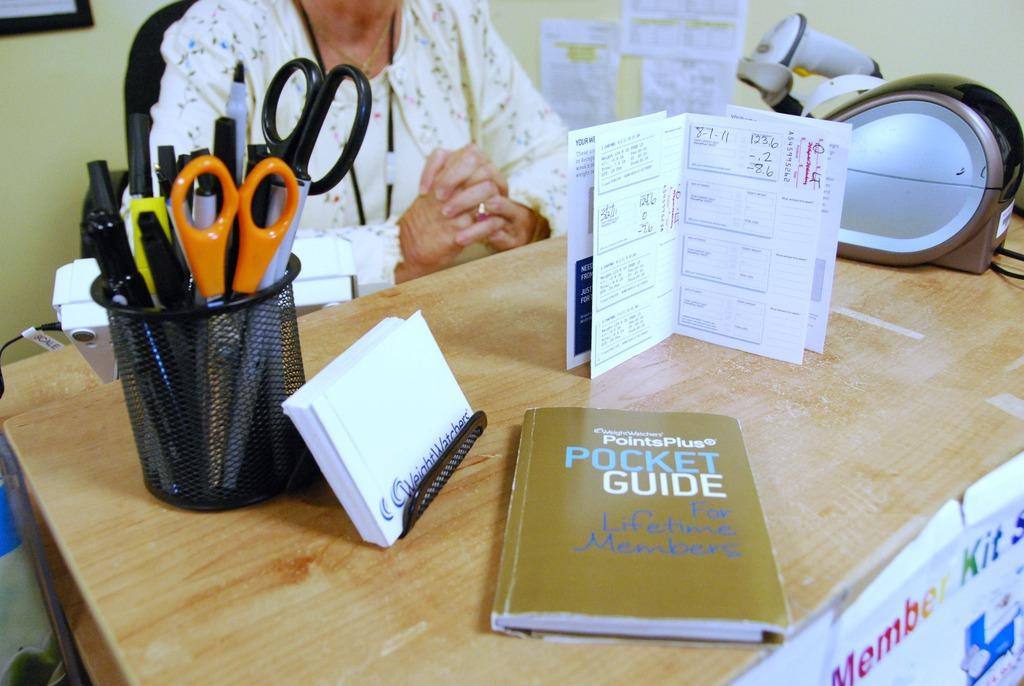What is the first word seen on the poster in the corner?
Your response must be concise. Member. What kind of guide is this?
Offer a terse response. Pocket. 